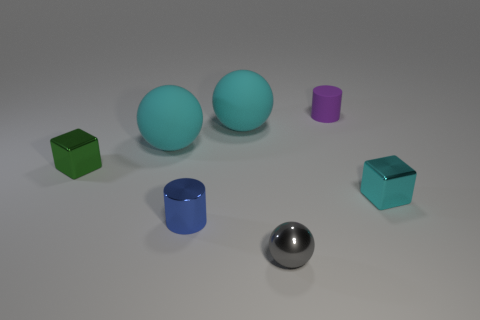Is the number of shiny cubes in front of the blue metallic thing less than the number of large purple cylinders?
Your response must be concise. No. Is the size of the purple cylinder the same as the gray metallic thing?
Provide a succinct answer. Yes. There is a gray object that is the same material as the cyan cube; what is its size?
Make the answer very short. Small. How many small metal objects are the same color as the small sphere?
Provide a succinct answer. 0. Are there fewer small cyan blocks to the left of the purple thing than blue objects behind the small cyan metal object?
Offer a very short reply. No. Do the big object that is on the left side of the tiny blue object and the tiny cyan metal object have the same shape?
Your answer should be very brief. No. Are there any other things that are made of the same material as the tiny green object?
Give a very brief answer. Yes. Is the material of the object that is to the right of the purple matte cylinder the same as the small blue cylinder?
Your answer should be very brief. Yes. There is a cylinder behind the small cyan thing in front of the tiny shiny cube to the left of the tiny sphere; what is its material?
Your response must be concise. Rubber. What number of other objects are there of the same shape as the tiny purple matte object?
Give a very brief answer. 1. 